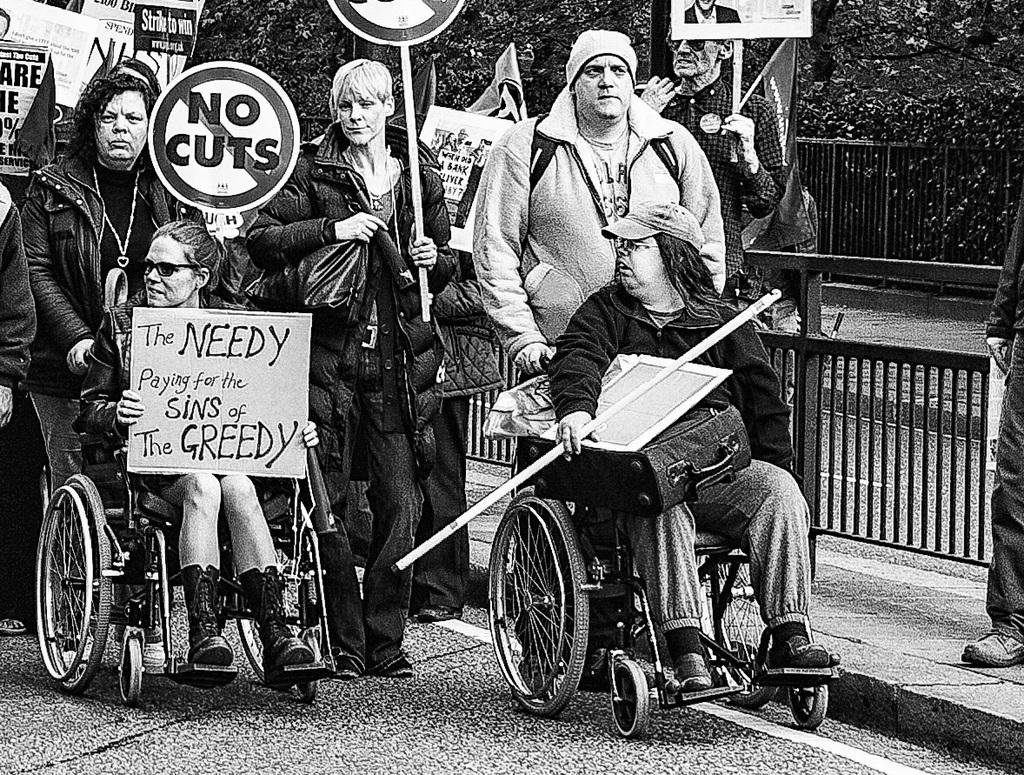Who or what is present in the image? There are people in the image. What are the people holding in their hands? The people are carrying pamphlets in their hands. What can be seen in the distance behind the people? There are trees and a road visible in the background of the image. Can you hear the creator of the pamphlets speaking in the image? There is no audio or indication of a creator's presence in the image, so it is not possible to hear them speaking. 